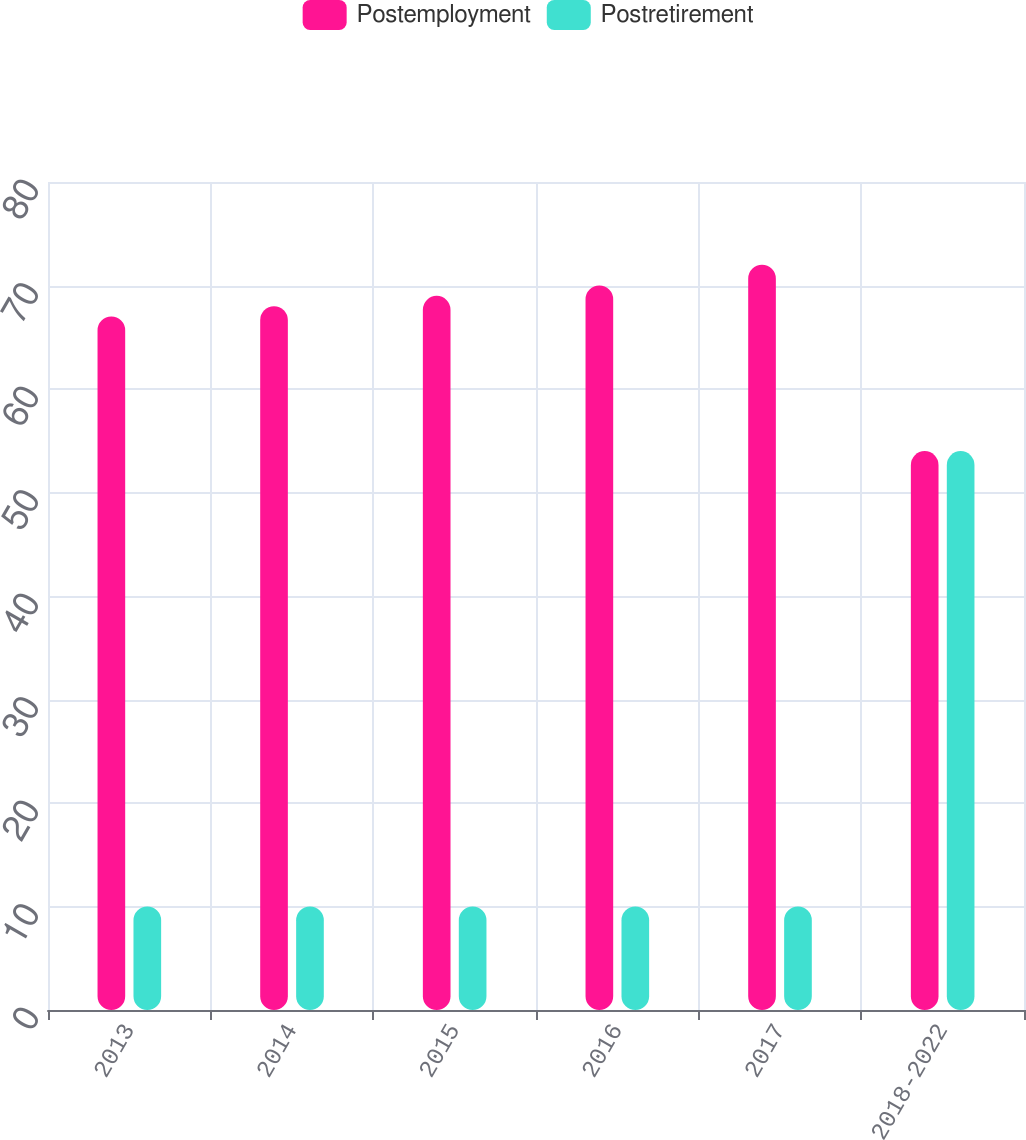Convert chart. <chart><loc_0><loc_0><loc_500><loc_500><stacked_bar_chart><ecel><fcel>2013<fcel>2014<fcel>2015<fcel>2016<fcel>2017<fcel>2018-2022<nl><fcel>Postemployment<fcel>67<fcel>68<fcel>69<fcel>70<fcel>72<fcel>54<nl><fcel>Postretirement<fcel>10<fcel>10<fcel>10<fcel>10<fcel>10<fcel>54<nl></chart> 